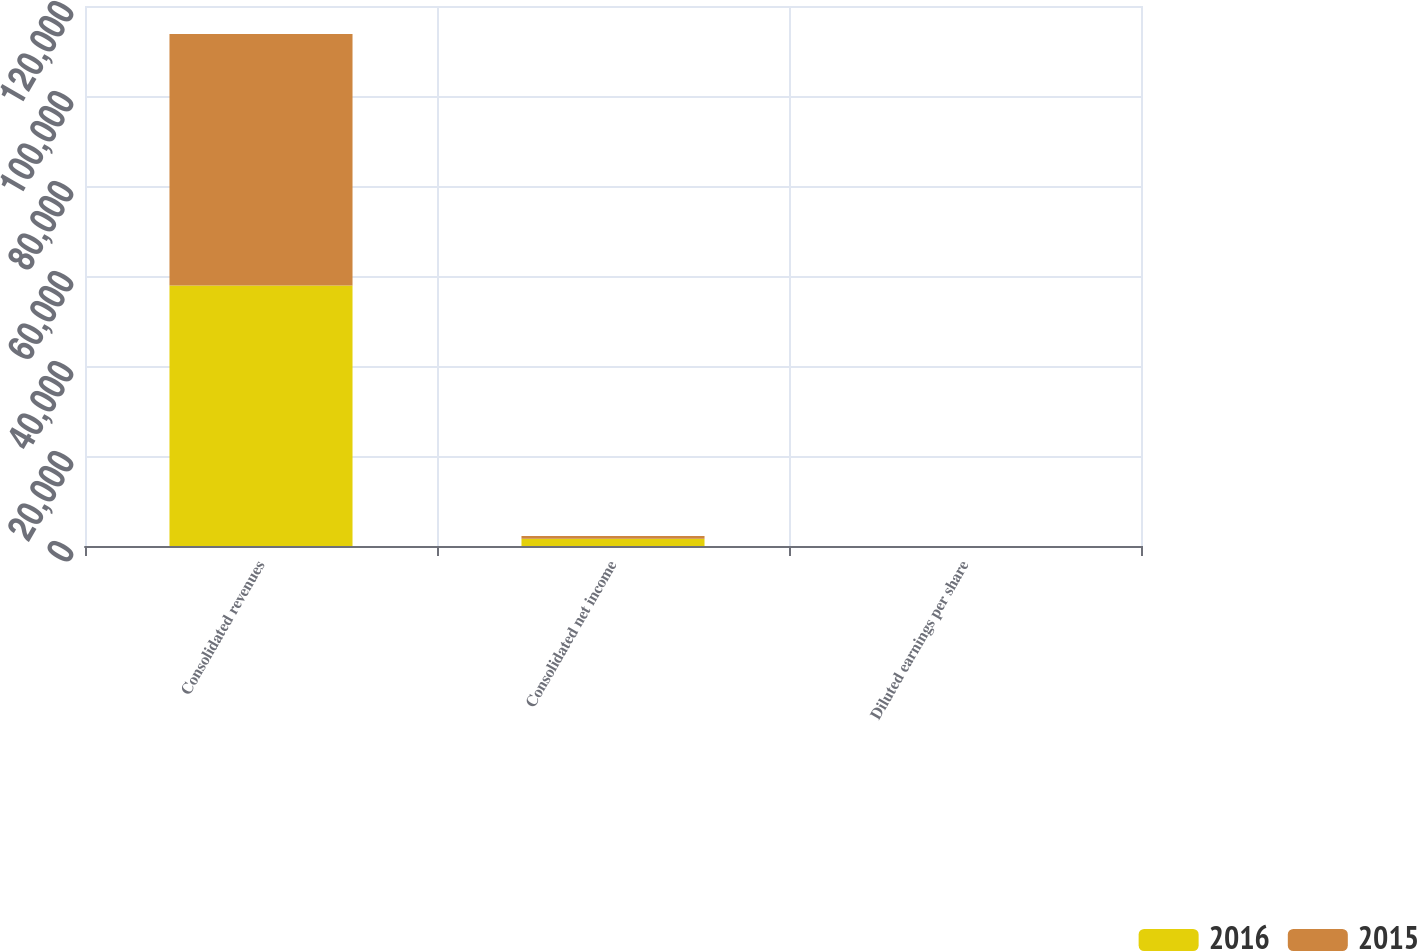Convert chart. <chart><loc_0><loc_0><loc_500><loc_500><stacked_bar_chart><ecel><fcel>Consolidated revenues<fcel>Consolidated net income<fcel>Diluted earnings per share<nl><fcel>2016<fcel>57899<fcel>1600<fcel>5.73<nl><fcel>2015<fcel>55862<fcel>638<fcel>2.22<nl></chart> 